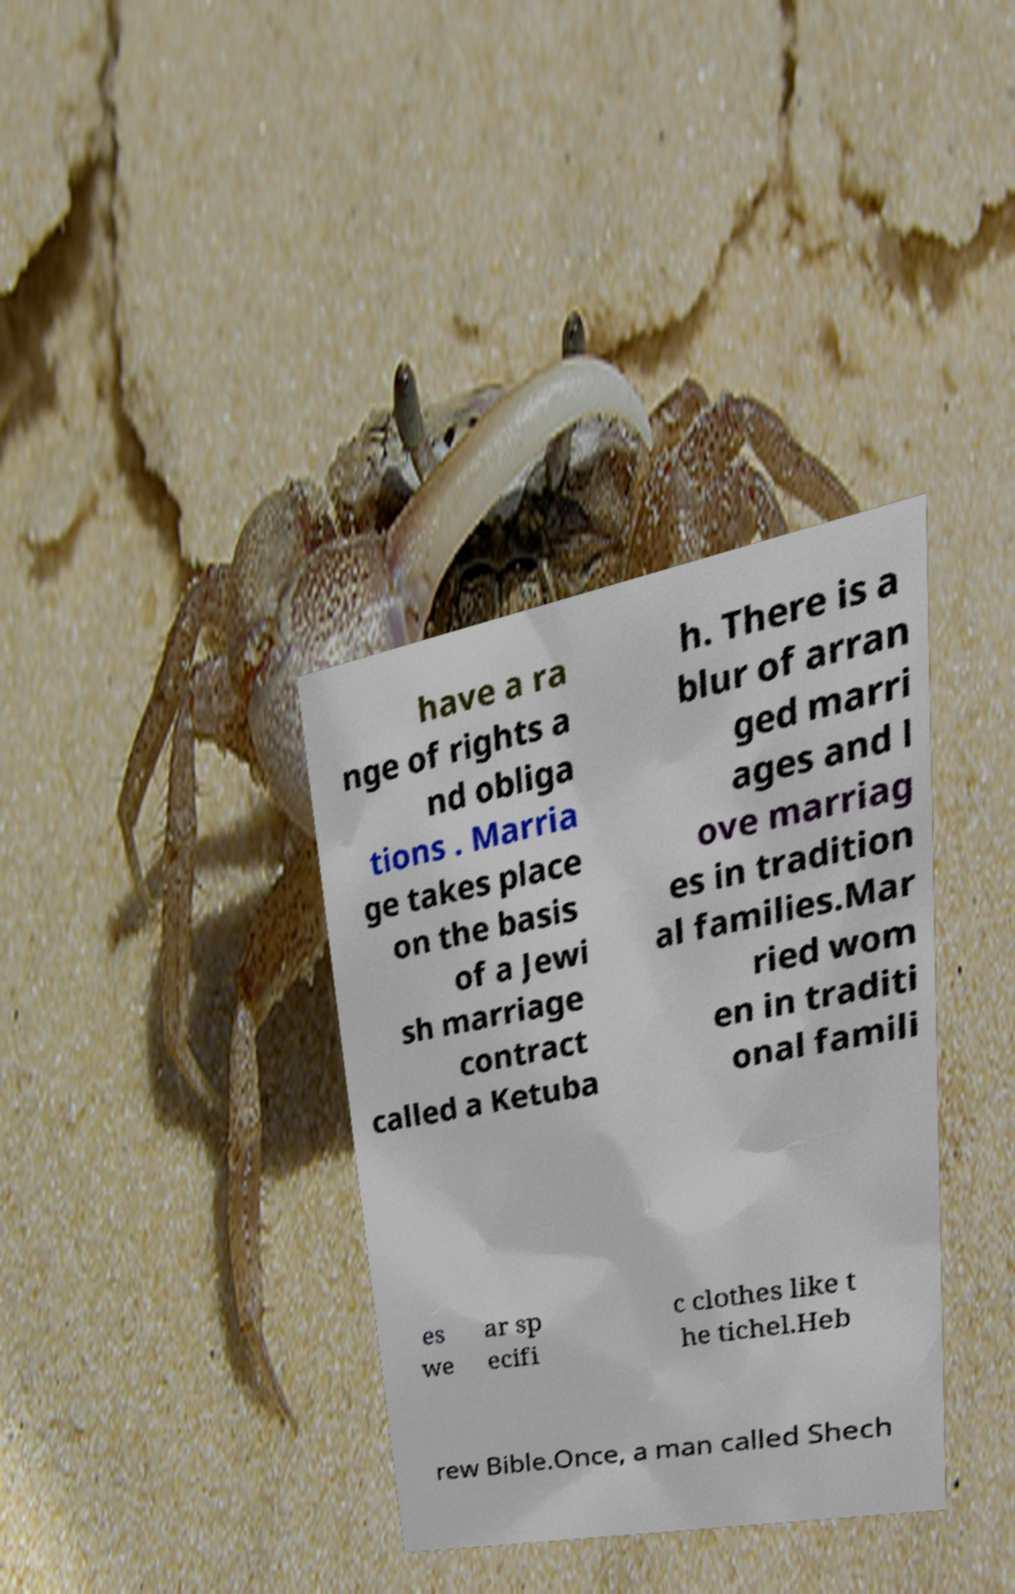Could you extract and type out the text from this image? have a ra nge of rights a nd obliga tions . Marria ge takes place on the basis of a Jewi sh marriage contract called a Ketuba h. There is a blur of arran ged marri ages and l ove marriag es in tradition al families.Mar ried wom en in traditi onal famili es we ar sp ecifi c clothes like t he tichel.Heb rew Bible.Once, a man called Shech 